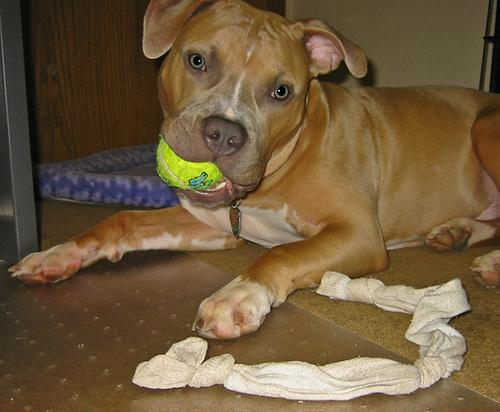What are some health concerns commonly associated with this dog breed? American Staffordshire Terriers, like the one in the image, are generally robust but can be predisposed to certain health issues. Common concerns include hip dysplasia, allergic dermatitis, and heart diseases. Regular vet check-ups and maintaining an appropriate diet and exercise regime can help manage these risks. 